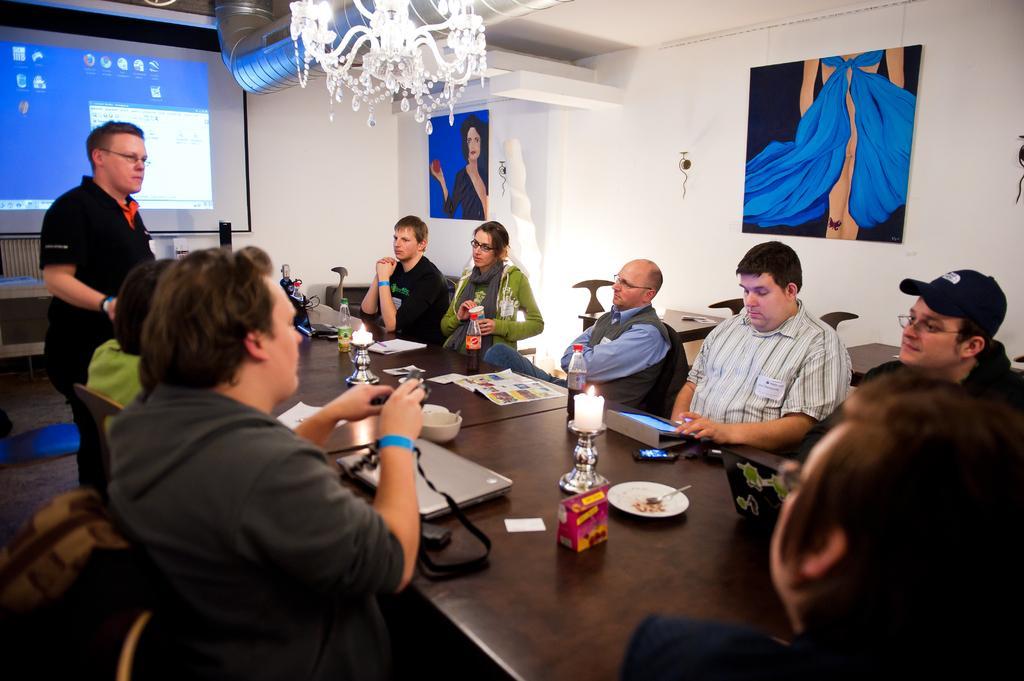Describe this image in one or two sentences. In this picture we can see some people sitting on chairs and a man standing and in front of them we can see papers, bowl, plate, candles, laptops, box and some objects on tables and in the background we can see a chandelier, screen, pipe, posters, walls. 